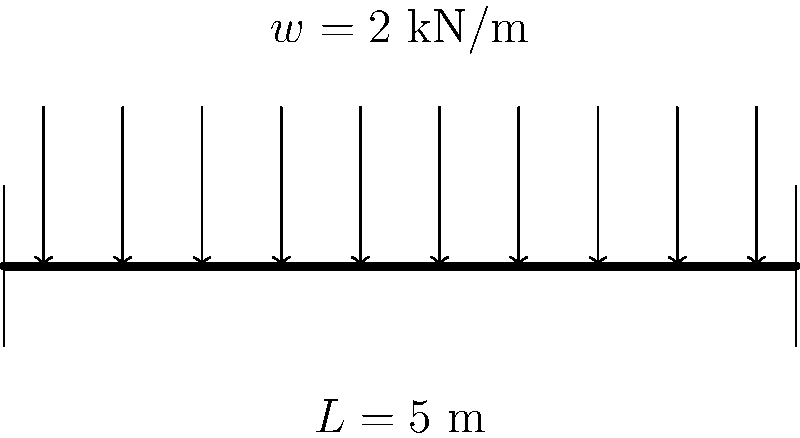A simple beam of length 5 meters is supported at both ends and carries a uniformly distributed load of 2 kN/m along its entire length. What is the maximum bending moment in the beam? To find the maximum bending moment in a simple beam with a uniformly distributed load, we can follow these steps:

1. Identify the given information:
   - Beam length, $L = 5$ m
   - Uniformly distributed load, $w = 2$ kN/m

2. Calculate the total load on the beam:
   Total load = $w \times L = 2 \text{ kN/m} \times 5 \text{ m} = 10 \text{ kN}$

3. For a simple beam with uniformly distributed load, the maximum bending moment occurs at the middle of the beam and is given by the formula:

   $M_{max} = \frac{wL^2}{8}$

4. Substitute the values into the formula:
   $M_{max} = \frac{2 \text{ kN/m} \times (5 \text{ m})^2}{8}$

5. Calculate the result:
   $M_{max} = \frac{2 \times 25}{8} = \frac{50}{8} = 6.25 \text{ kN·m}$

Therefore, the maximum bending moment in the beam is 6.25 kN·m.
Answer: 6.25 kN·m 